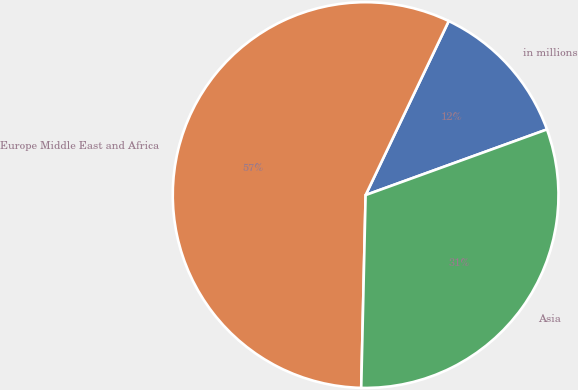<chart> <loc_0><loc_0><loc_500><loc_500><pie_chart><fcel>in millions<fcel>Europe Middle East and Africa<fcel>Asia<nl><fcel>12.38%<fcel>56.73%<fcel>30.89%<nl></chart> 